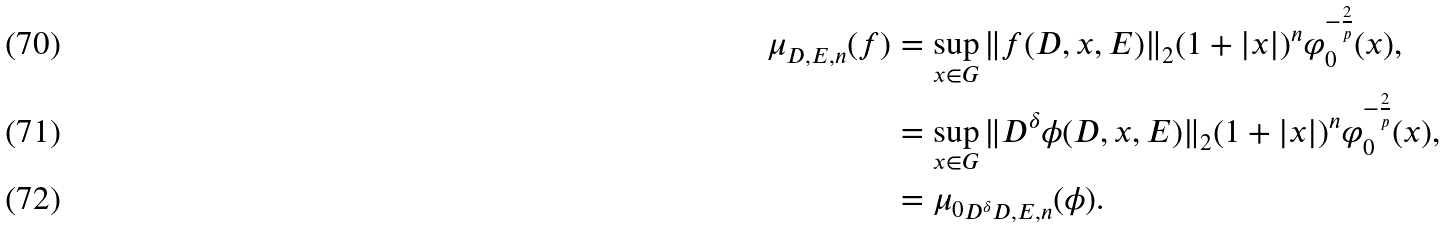Convert formula to latex. <formula><loc_0><loc_0><loc_500><loc_500>\mu _ { D , E , n } ( f ) & = \sup _ { x \in G } \| f ( D , x , E ) \| _ { 2 } ( 1 + | x | ) ^ { n } \varphi ^ { - \frac { 2 } { p } } _ { 0 } ( x ) , \\ & = \sup _ { x \in G } \| D ^ { \delta } \phi ( D , x , E ) \| _ { 2 } ( 1 + | x | ) ^ { n } \varphi ^ { - \frac { 2 } { p } } _ { 0 } ( x ) , \\ & = { \mu _ { 0 } } _ { D ^ { \delta } D , E , n } ( \phi ) .</formula> 